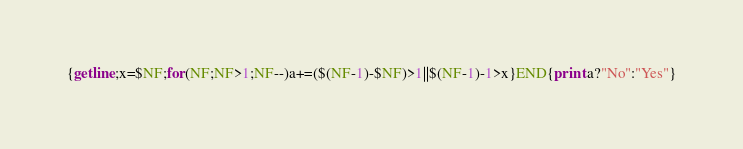<code> <loc_0><loc_0><loc_500><loc_500><_Awk_>{getline;x=$NF;for(NF;NF>1;NF--)a+=($(NF-1)-$NF)>1||$(NF-1)-1>x}END{print a?"No":"Yes"}</code> 